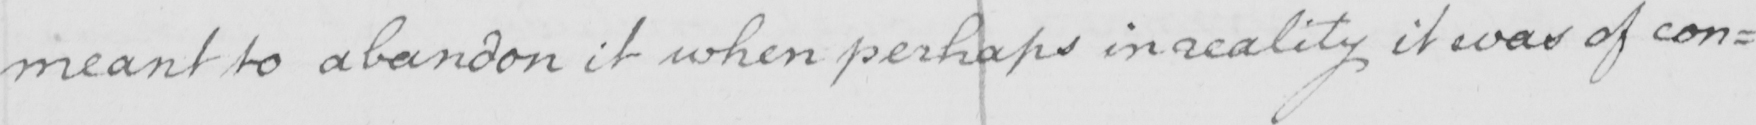Please transcribe the handwritten text in this image. meant to abandon it when perhaps in reality it was of con : 